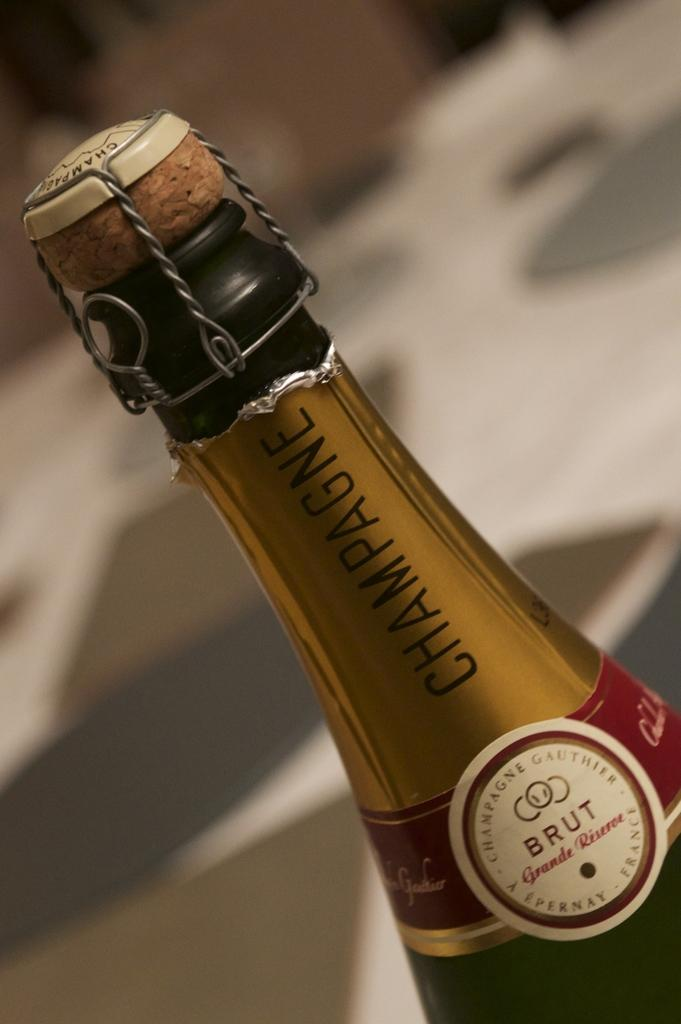Provide a one-sentence caption for the provided image. THE WRAPED CORK TOP BOTTLE OF BRUT CHAMPAGNE. 